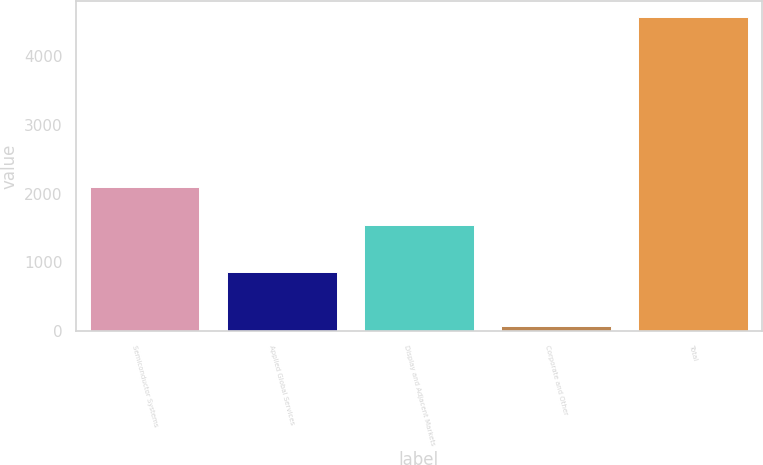<chart> <loc_0><loc_0><loc_500><loc_500><bar_chart><fcel>Semiconductor Systems<fcel>Applied Global Services<fcel>Display and Adjacent Markets<fcel>Corporate and Other<fcel>Total<nl><fcel>2098<fcel>866<fcel>1539<fcel>75<fcel>4578<nl></chart> 